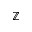<formula> <loc_0><loc_0><loc_500><loc_500>\mathbb { Z }</formula> 